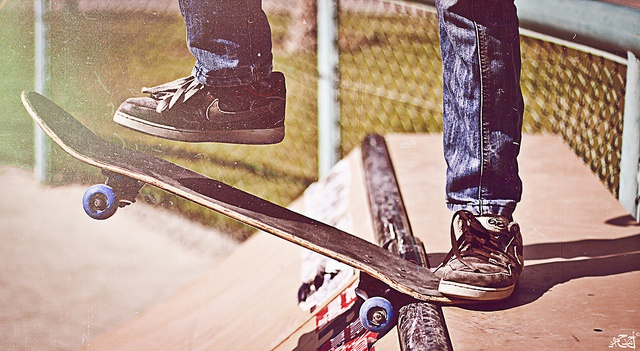Describe the objects in this image and their specific colors. I can see people in tan, maroon, brown, black, and lightgray tones and skateboard in tan, gray, maroon, darkgray, and white tones in this image. 